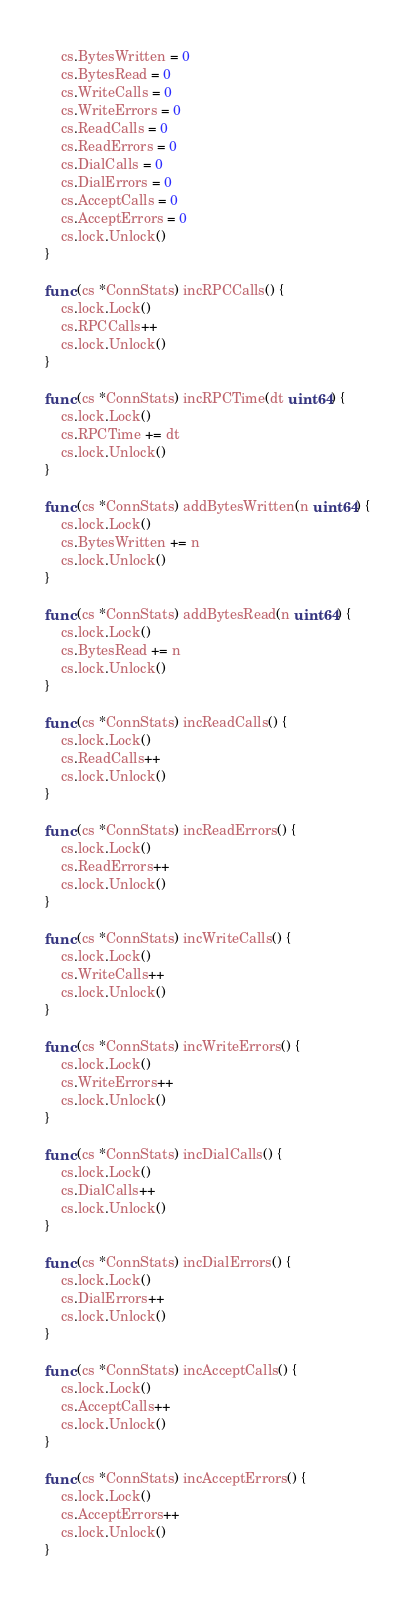<code> <loc_0><loc_0><loc_500><loc_500><_Go_>	cs.BytesWritten = 0
	cs.BytesRead = 0
	cs.WriteCalls = 0
	cs.WriteErrors = 0
	cs.ReadCalls = 0
	cs.ReadErrors = 0
	cs.DialCalls = 0
	cs.DialErrors = 0
	cs.AcceptCalls = 0
	cs.AcceptErrors = 0
	cs.lock.Unlock()
}

func (cs *ConnStats) incRPCCalls() {
	cs.lock.Lock()
	cs.RPCCalls++
	cs.lock.Unlock()
}

func (cs *ConnStats) incRPCTime(dt uint64) {
	cs.lock.Lock()
	cs.RPCTime += dt
	cs.lock.Unlock()
}

func (cs *ConnStats) addBytesWritten(n uint64) {
	cs.lock.Lock()
	cs.BytesWritten += n
	cs.lock.Unlock()
}

func (cs *ConnStats) addBytesRead(n uint64) {
	cs.lock.Lock()
	cs.BytesRead += n
	cs.lock.Unlock()
}

func (cs *ConnStats) incReadCalls() {
	cs.lock.Lock()
	cs.ReadCalls++
	cs.lock.Unlock()
}

func (cs *ConnStats) incReadErrors() {
	cs.lock.Lock()
	cs.ReadErrors++
	cs.lock.Unlock()
}

func (cs *ConnStats) incWriteCalls() {
	cs.lock.Lock()
	cs.WriteCalls++
	cs.lock.Unlock()
}

func (cs *ConnStats) incWriteErrors() {
	cs.lock.Lock()
	cs.WriteErrors++
	cs.lock.Unlock()
}

func (cs *ConnStats) incDialCalls() {
	cs.lock.Lock()
	cs.DialCalls++
	cs.lock.Unlock()
}

func (cs *ConnStats) incDialErrors() {
	cs.lock.Lock()
	cs.DialErrors++
	cs.lock.Unlock()
}

func (cs *ConnStats) incAcceptCalls() {
	cs.lock.Lock()
	cs.AcceptCalls++
	cs.lock.Unlock()
}

func (cs *ConnStats) incAcceptErrors() {
	cs.lock.Lock()
	cs.AcceptErrors++
	cs.lock.Unlock()
}
</code> 